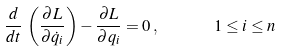<formula> <loc_0><loc_0><loc_500><loc_500>\frac { d } { d t } \, \left ( \frac { \partial L } { \partial \dot { q } _ { i } } \right ) - \frac { \partial L } { \partial q _ { i } } = 0 \, , \ \quad \ 1 \leq i \leq n \,</formula> 